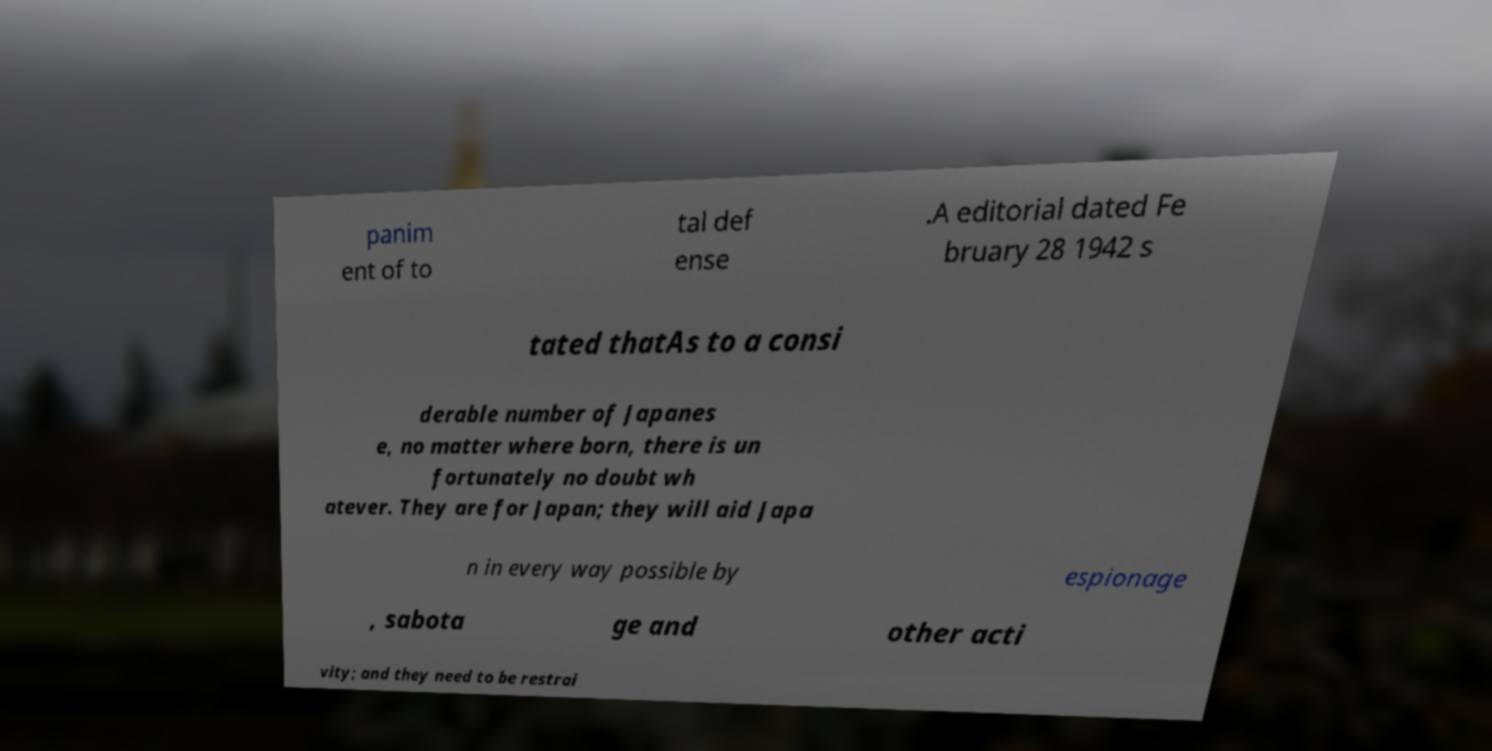There's text embedded in this image that I need extracted. Can you transcribe it verbatim? panim ent of to tal def ense .A editorial dated Fe bruary 28 1942 s tated thatAs to a consi derable number of Japanes e, no matter where born, there is un fortunately no doubt wh atever. They are for Japan; they will aid Japa n in every way possible by espionage , sabota ge and other acti vity; and they need to be restrai 